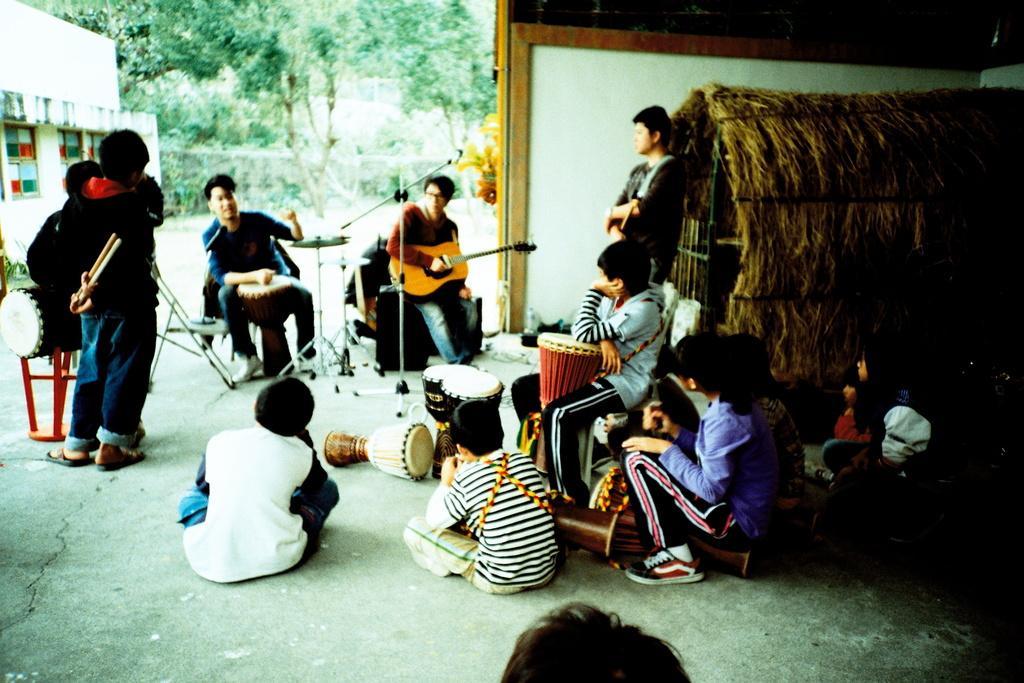Please provide a concise description of this image. In the center of the image there are people playing musical instruments. In the background of the image there are trees. There is a house. To the right side of the image there is a hut. 